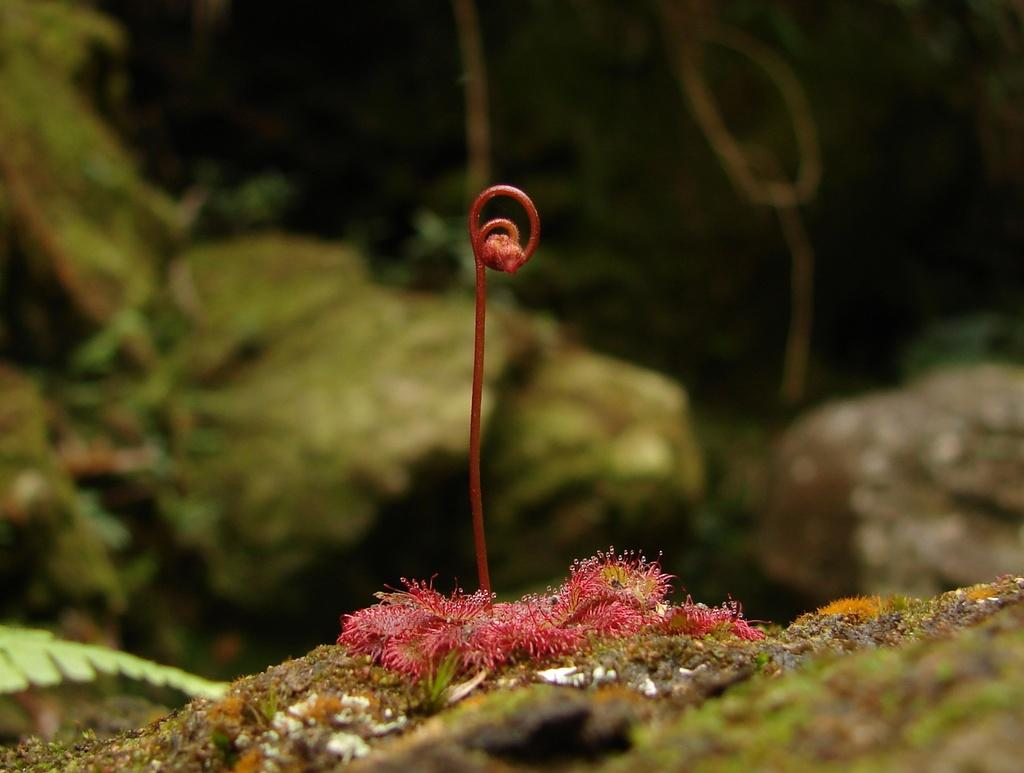What is the main subject of the image? There is a flower in the image. Where is the flower located? The flower is on the ground. What color is the flower? The flower is pink. What can be seen on the left side of the image? There are green leaves on the left side of the image. What type of drain is visible in the image? There is no drain present in the image. What flavor of cord can be seen in the image? There is no cord present in the image, and therefore no flavor can be determined. 